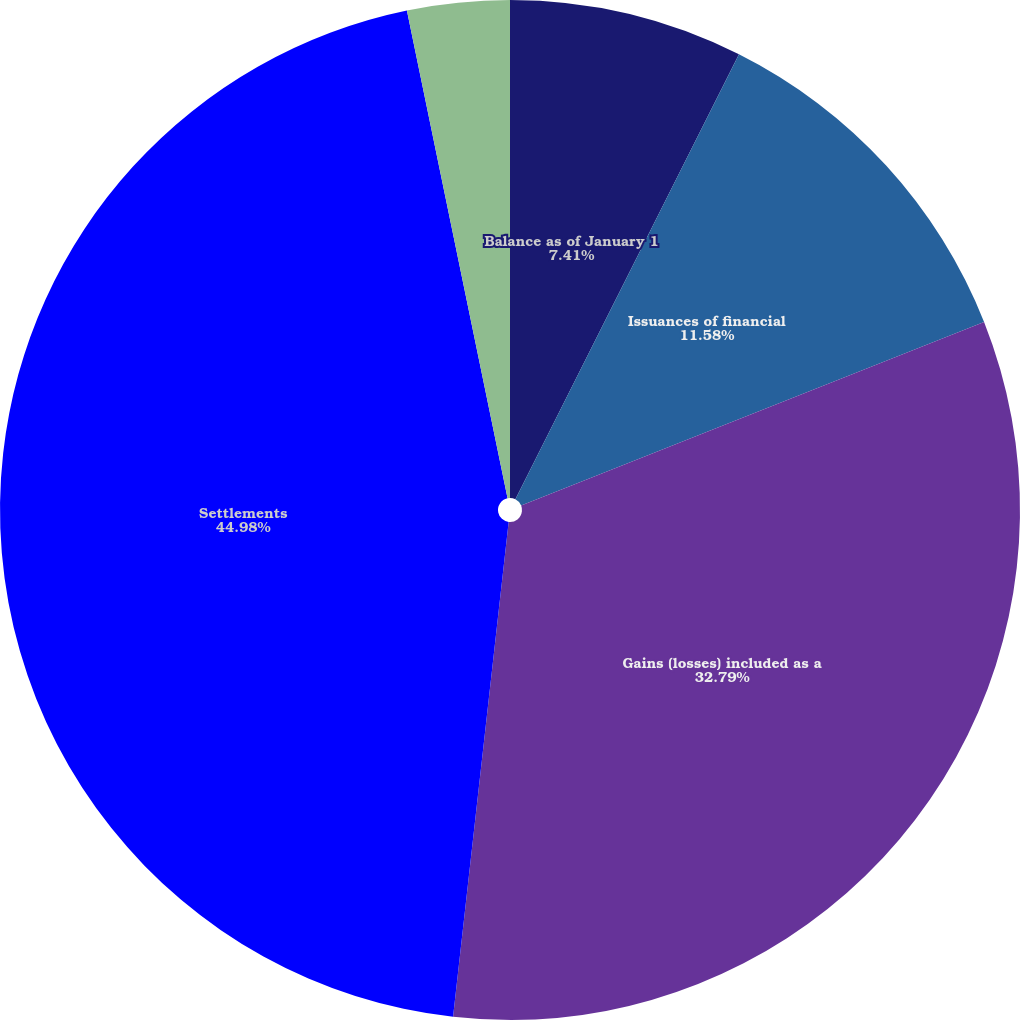Convert chart. <chart><loc_0><loc_0><loc_500><loc_500><pie_chart><fcel>Balance as of January 1<fcel>Issuances of financial<fcel>Gains (losses) included as a<fcel>Settlements<fcel>Balance as of December 31<nl><fcel>7.41%<fcel>11.58%<fcel>32.79%<fcel>44.98%<fcel>3.24%<nl></chart> 